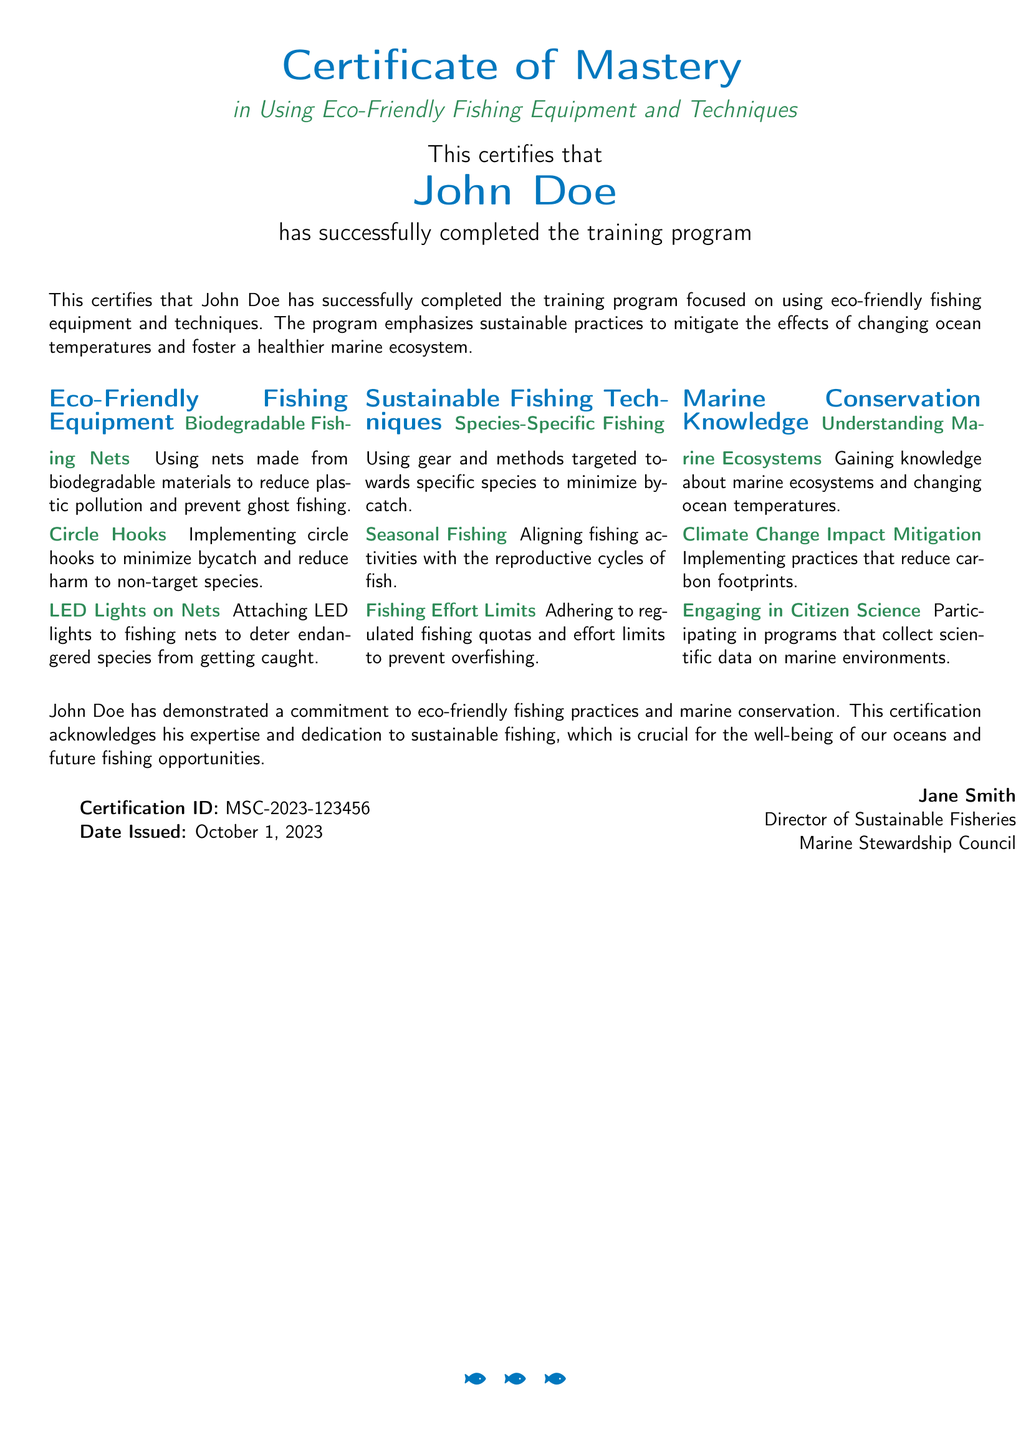What is the title of the certificate? The title of the certificate is prominently displayed at the top of the document, which is "Certificate of Mastery."
Answer: Certificate of Mastery Who is the certificate awarded to? The name of the person awarded the certificate is mentioned in a prominent position.
Answer: John Doe What is the certification ID? The certification ID is specified at the end of the document.
Answer: MSC-2023-123456 What is the date issued? The date issued is listed next to the certification ID at the bottom of the document.
Answer: October 1, 2023 Which organization issued the certificate? The organization that issued the certificate is indicated by the title at the bottom of the document.
Answer: Marine Stewardship Council What type of fishing equipment is discussed in the document? The document mentions specific eco-friendly fishing equipment that promotes sustainability.
Answer: Biodegradable Fishing Nets What sustainable fishing technique is highlighted? The document lists techniques helping minimize environmental impact through targeted practices.
Answer: Seasonal Fishing What is the main goal of the training program? The goal of the training program is stated as a method to address a significant issue affecting marine life.
Answer: Mitigate the effects of changing ocean temperatures What is a key knowledge area covered in the training? The certificate details knowledge necessary for understanding current environmental impacts.
Answer: Understanding Marine Ecosystems 